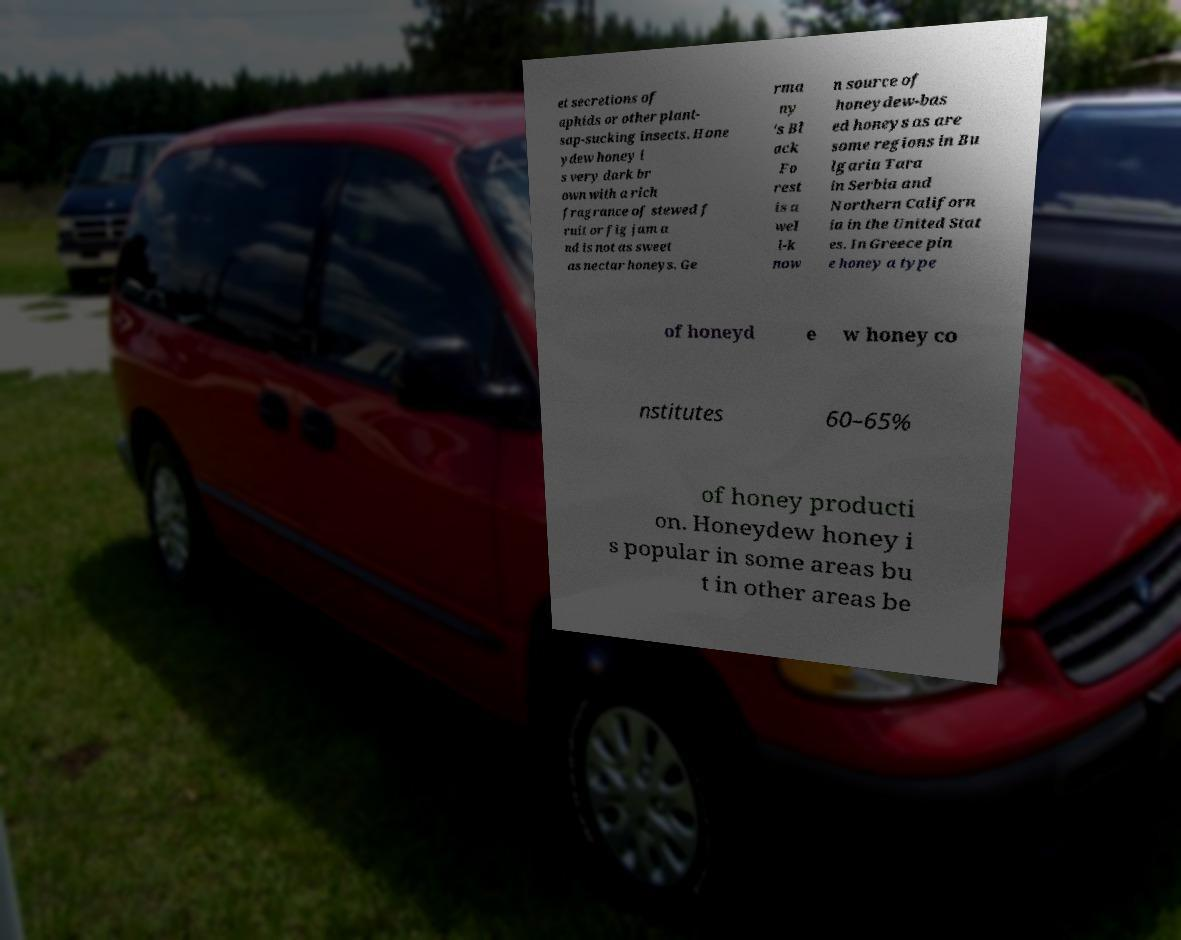Can you accurately transcribe the text from the provided image for me? et secretions of aphids or other plant- sap-sucking insects. Hone ydew honey i s very dark br own with a rich fragrance of stewed f ruit or fig jam a nd is not as sweet as nectar honeys. Ge rma ny 's Bl ack Fo rest is a wel l-k now n source of honeydew-bas ed honeys as are some regions in Bu lgaria Tara in Serbia and Northern Californ ia in the United Stat es. In Greece pin e honey a type of honeyd e w honey co nstitutes 60–65% of honey producti on. Honeydew honey i s popular in some areas bu t in other areas be 